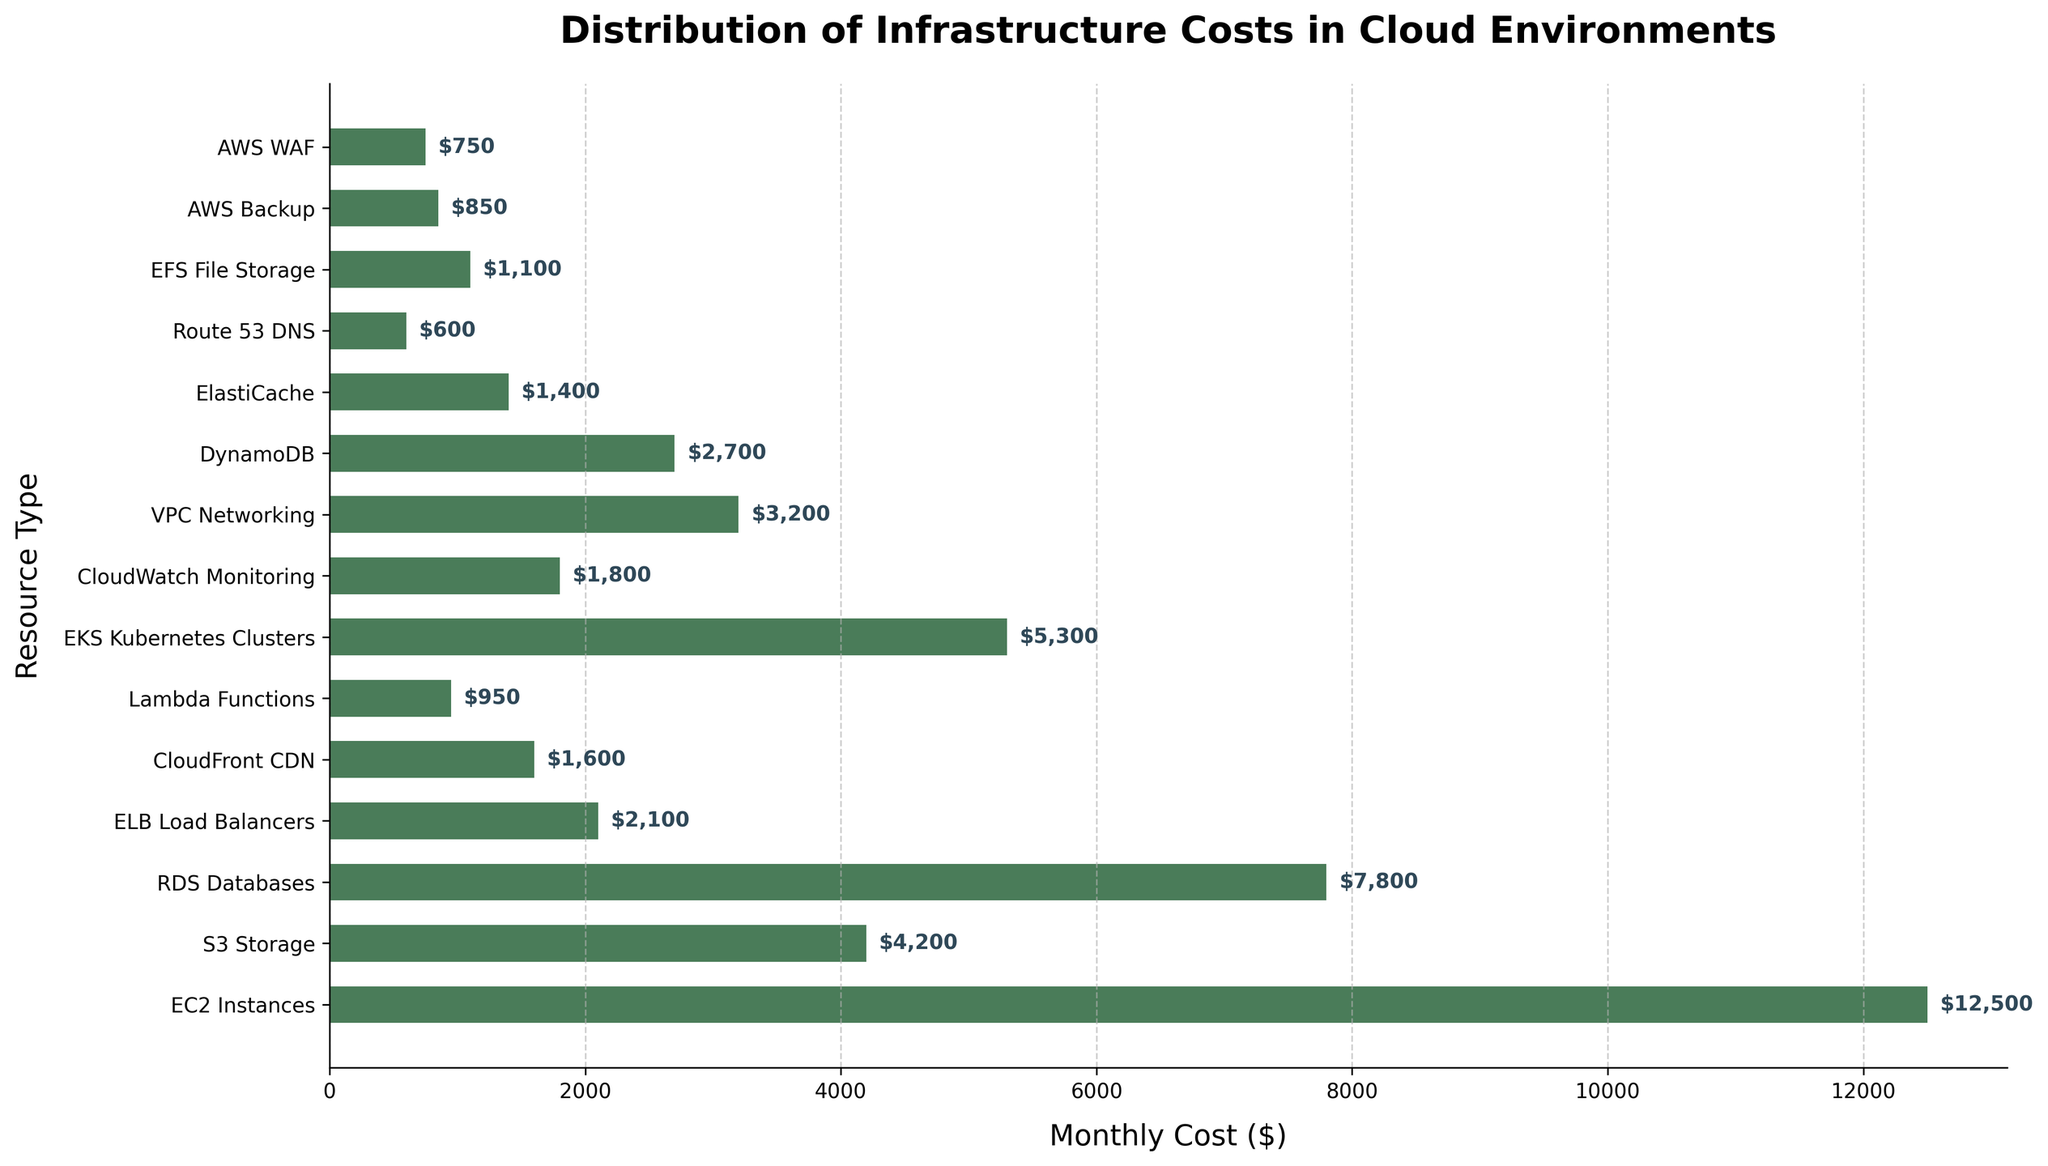Which resource type has the highest monthly cost? EC2 Instances have the highest monthly cost, as indicated by the longest bar in the horizontal bar chart.
Answer: EC2 Instances How much more does EC2 Instances cost compared to RDS Databases? The monthly cost of EC2 Instances is $12,500, and the cost of RDS Databases is $7,800. The difference is $12,500 - $7,800 = $4,700.
Answer: $4,700 What is the combined monthly cost of CloudFront CDN, Lambda Functions, and AWS Backup? The monthly costs for CloudFront CDN, Lambda Functions, and AWS Backup are $1,600, $950, and $850 respectively. The combined cost is $1,600 + $950 + $850 = $3,400.
Answer: $3,400 Which resource types have a monthly cost less than $1,000? The resource types with a monthly cost less than $1,000 are Lambda Functions ($950), Route 53 DNS ($600), AWS Backup ($850), and AWS WAF ($750).
Answer: Lambda Functions, Route 53 DNS, AWS Backup, AWS WAF How many resource types have a monthly cost greater than $5,000? The resource types with monthly costs greater than $5,000 are EC2 Instances ($12,500), RDS Databases ($7,800), and EKS Kubernetes Clusters ($5,300). Therefore, there are 3 resource types.
Answer: 3 Which resource type has the smallest monthly cost? Route 53 DNS has the smallest monthly cost, as indicated by the shortest bar in the horizontal bar chart.
Answer: Route 53 DNS What is the average monthly cost of S3 Storage, CloudWatch Monitoring, and VPC Networking? The monthly costs for S3 Storage, CloudWatch Monitoring, and VPC Networking are $4,200, $1,800, and $3,200 respectively. The average cost is calculated as ($4,200 + $1,800 + $3,200) / 3 = $3,066.67.
Answer: $3,066.67 Are there more resource types with costs above or below $2,000? To determine this, count the number of resource types with costs above $2,000 (7 resources: EC2 Instances, S3 Storage, RDS Databases, EKS Kubernetes Clusters, ELB Load Balancers, DynamoDB, VPC Networking) and below $2,000 (8 resources: CloudFront CDN, Lambda Functions, CloudWatch Monitoring, ElastiCache, Route 53 DNS, EFS File Storage, AWS Backup, AWS WAF). There are more resources with costs below $2,000.
Answer: Below $2,000 Which resource types have costs between $1,000 and $2,500? The resource types with monthly costs between $1,000 and $2,500 are ELB Load Balancers ($2,100), CloudFront CDN ($1,600), CloudWatch Monitoring ($1,800), ElastiCache ($1,400), and EFS File Storage ($1,100).
Answer: ELB Load Balancers, CloudFront CDN, CloudWatch Monitoring, ElastiCache, EFS File Storage What is the total cost of all resource types displayed in the chart? Summing up the monthly costs of all resource types: $12,500 (EC2 Instances) + $4,200 (S3 Storage) + $7,800 (RDS Databases) + $2,100 (ELB Load Balancers) + $1,600 (CloudFront CDN) + $950 (Lambda Functions) + $5,300 (EKS Kubernetes Clusters) + $1,800 (CloudWatch Monitoring) + $3,200 (VPC Networking) + $2,700 (DynamoDB) + $1,400 (ElastiCache) + $600 (Route 53 DNS) + $1,100 (EFS File Storage) + $850 (AWS Backup) + $750 (AWS WAF) equals $46,850.
Answer: $46,850 